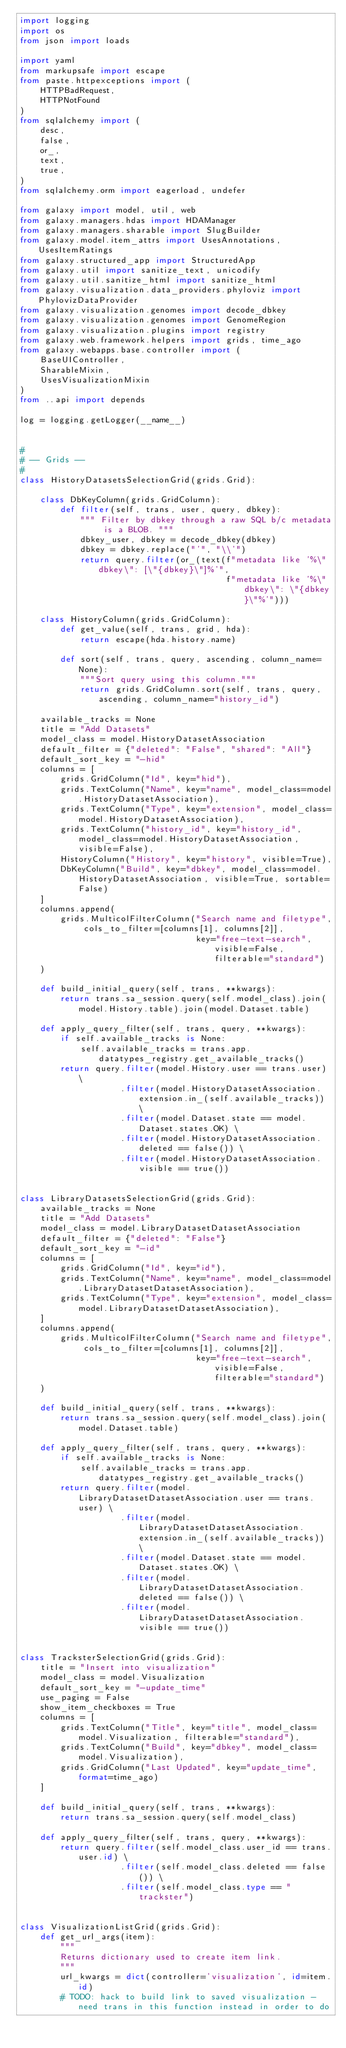Convert code to text. <code><loc_0><loc_0><loc_500><loc_500><_Python_>import logging
import os
from json import loads

import yaml
from markupsafe import escape
from paste.httpexceptions import (
    HTTPBadRequest,
    HTTPNotFound
)
from sqlalchemy import (
    desc,
    false,
    or_,
    text,
    true,
)
from sqlalchemy.orm import eagerload, undefer

from galaxy import model, util, web
from galaxy.managers.hdas import HDAManager
from galaxy.managers.sharable import SlugBuilder
from galaxy.model.item_attrs import UsesAnnotations, UsesItemRatings
from galaxy.structured_app import StructuredApp
from galaxy.util import sanitize_text, unicodify
from galaxy.util.sanitize_html import sanitize_html
from galaxy.visualization.data_providers.phyloviz import PhylovizDataProvider
from galaxy.visualization.genomes import decode_dbkey
from galaxy.visualization.genomes import GenomeRegion
from galaxy.visualization.plugins import registry
from galaxy.web.framework.helpers import grids, time_ago
from galaxy.webapps.base.controller import (
    BaseUIController,
    SharableMixin,
    UsesVisualizationMixin
)
from ..api import depends

log = logging.getLogger(__name__)


#
# -- Grids --
#
class HistoryDatasetsSelectionGrid(grids.Grid):

    class DbKeyColumn(grids.GridColumn):
        def filter(self, trans, user, query, dbkey):
            """ Filter by dbkey through a raw SQL b/c metadata is a BLOB. """
            dbkey_user, dbkey = decode_dbkey(dbkey)
            dbkey = dbkey.replace("'", "\\'")
            return query.filter(or_(text(f"metadata like '%\"dbkey\": [\"{dbkey}\"]%'",
                                         f"metadata like '%\"dbkey\": \"{dbkey}\"%'")))

    class HistoryColumn(grids.GridColumn):
        def get_value(self, trans, grid, hda):
            return escape(hda.history.name)

        def sort(self, trans, query, ascending, column_name=None):
            """Sort query using this column."""
            return grids.GridColumn.sort(self, trans, query, ascending, column_name="history_id")

    available_tracks = None
    title = "Add Datasets"
    model_class = model.HistoryDatasetAssociation
    default_filter = {"deleted": "False", "shared": "All"}
    default_sort_key = "-hid"
    columns = [
        grids.GridColumn("Id", key="hid"),
        grids.TextColumn("Name", key="name", model_class=model.HistoryDatasetAssociation),
        grids.TextColumn("Type", key="extension", model_class=model.HistoryDatasetAssociation),
        grids.TextColumn("history_id", key="history_id", model_class=model.HistoryDatasetAssociation, visible=False),
        HistoryColumn("History", key="history", visible=True),
        DbKeyColumn("Build", key="dbkey", model_class=model.HistoryDatasetAssociation, visible=True, sortable=False)
    ]
    columns.append(
        grids.MulticolFilterColumn("Search name and filetype", cols_to_filter=[columns[1], columns[2]],
                                   key="free-text-search", visible=False, filterable="standard")
    )

    def build_initial_query(self, trans, **kwargs):
        return trans.sa_session.query(self.model_class).join(model.History.table).join(model.Dataset.table)

    def apply_query_filter(self, trans, query, **kwargs):
        if self.available_tracks is None:
            self.available_tracks = trans.app.datatypes_registry.get_available_tracks()
        return query.filter(model.History.user == trans.user) \
                    .filter(model.HistoryDatasetAssociation.extension.in_(self.available_tracks)) \
                    .filter(model.Dataset.state == model.Dataset.states.OK) \
                    .filter(model.HistoryDatasetAssociation.deleted == false()) \
                    .filter(model.HistoryDatasetAssociation.visible == true())


class LibraryDatasetsSelectionGrid(grids.Grid):
    available_tracks = None
    title = "Add Datasets"
    model_class = model.LibraryDatasetDatasetAssociation
    default_filter = {"deleted": "False"}
    default_sort_key = "-id"
    columns = [
        grids.GridColumn("Id", key="id"),
        grids.TextColumn("Name", key="name", model_class=model.LibraryDatasetDatasetAssociation),
        grids.TextColumn("Type", key="extension", model_class=model.LibraryDatasetDatasetAssociation),
    ]
    columns.append(
        grids.MulticolFilterColumn("Search name and filetype", cols_to_filter=[columns[1], columns[2]],
                                   key="free-text-search", visible=False, filterable="standard")
    )

    def build_initial_query(self, trans, **kwargs):
        return trans.sa_session.query(self.model_class).join(model.Dataset.table)

    def apply_query_filter(self, trans, query, **kwargs):
        if self.available_tracks is None:
            self.available_tracks = trans.app.datatypes_registry.get_available_tracks()
        return query.filter(model.LibraryDatasetDatasetAssociation.user == trans.user) \
                    .filter(model.LibraryDatasetDatasetAssociation.extension.in_(self.available_tracks)) \
                    .filter(model.Dataset.state == model.Dataset.states.OK) \
                    .filter(model.LibraryDatasetDatasetAssociation.deleted == false()) \
                    .filter(model.LibraryDatasetDatasetAssociation.visible == true())


class TracksterSelectionGrid(grids.Grid):
    title = "Insert into visualization"
    model_class = model.Visualization
    default_sort_key = "-update_time"
    use_paging = False
    show_item_checkboxes = True
    columns = [
        grids.TextColumn("Title", key="title", model_class=model.Visualization, filterable="standard"),
        grids.TextColumn("Build", key="dbkey", model_class=model.Visualization),
        grids.GridColumn("Last Updated", key="update_time", format=time_ago)
    ]

    def build_initial_query(self, trans, **kwargs):
        return trans.sa_session.query(self.model_class)

    def apply_query_filter(self, trans, query, **kwargs):
        return query.filter(self.model_class.user_id == trans.user.id) \
                    .filter(self.model_class.deleted == false()) \
                    .filter(self.model_class.type == "trackster")


class VisualizationListGrid(grids.Grid):
    def get_url_args(item):
        """
        Returns dictionary used to create item link.
        """
        url_kwargs = dict(controller='visualization', id=item.id)
        # TODO: hack to build link to saved visualization - need trans in this function instead in order to do</code> 